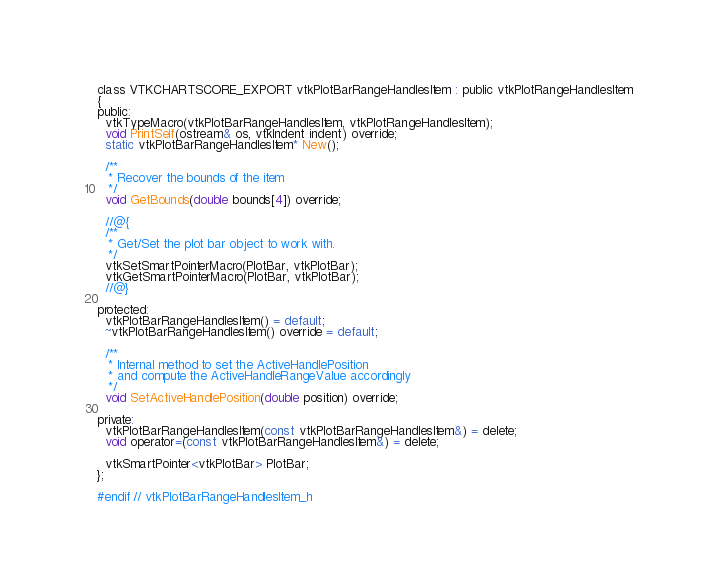<code> <loc_0><loc_0><loc_500><loc_500><_C_>class VTKCHARTSCORE_EXPORT vtkPlotBarRangeHandlesItem : public vtkPlotRangeHandlesItem
{
public:
  vtkTypeMacro(vtkPlotBarRangeHandlesItem, vtkPlotRangeHandlesItem);
  void PrintSelf(ostream& os, vtkIndent indent) override;
  static vtkPlotBarRangeHandlesItem* New();

  /**
   * Recover the bounds of the item
   */
  void GetBounds(double bounds[4]) override;

  //@{
  /**
   * Get/Set the plot bar object to work with.
   */
  vtkSetSmartPointerMacro(PlotBar, vtkPlotBar);
  vtkGetSmartPointerMacro(PlotBar, vtkPlotBar);
  //@}

protected:
  vtkPlotBarRangeHandlesItem() = default;
  ~vtkPlotBarRangeHandlesItem() override = default;

  /**
   * Internal method to set the ActiveHandlePosition
   * and compute the ActiveHandleRangeValue accordingly
   */
  void SetActiveHandlePosition(double position) override;

private:
  vtkPlotBarRangeHandlesItem(const vtkPlotBarRangeHandlesItem&) = delete;
  void operator=(const vtkPlotBarRangeHandlesItem&) = delete;

  vtkSmartPointer<vtkPlotBar> PlotBar;
};

#endif // vtkPlotBarRangeHandlesItem_h
</code> 